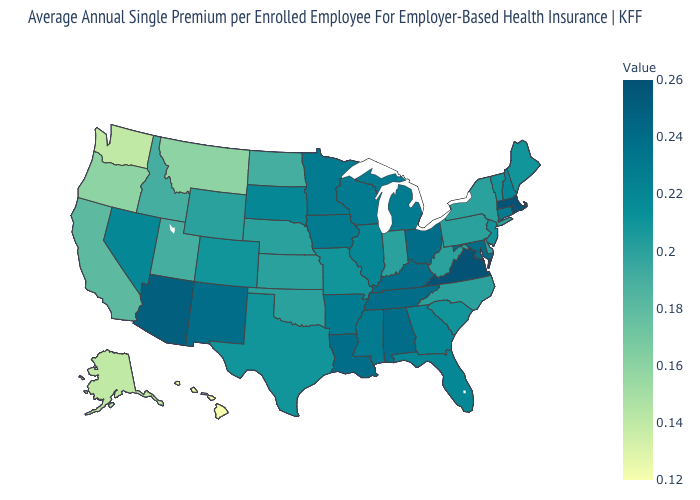Which states have the lowest value in the MidWest?
Give a very brief answer. North Dakota. Does Alaska have a higher value than Connecticut?
Write a very short answer. No. Among the states that border Mississippi , does Arkansas have the lowest value?
Be succinct. Yes. Among the states that border New Mexico , which have the highest value?
Answer briefly. Arizona. 